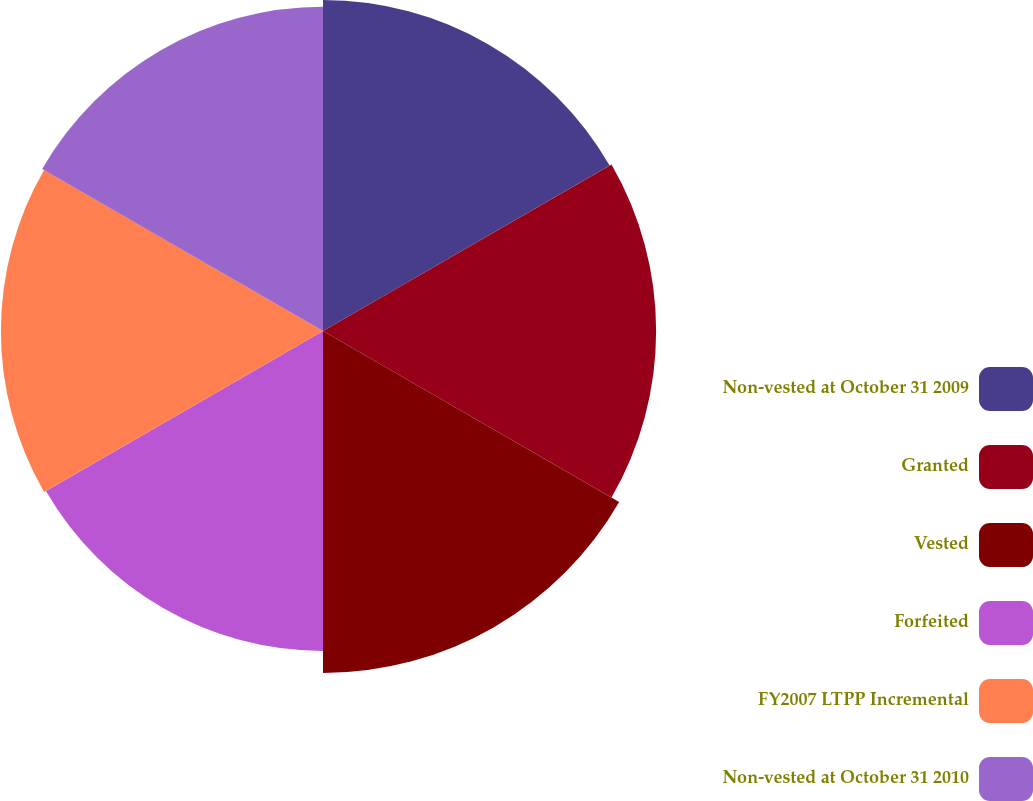Convert chart to OTSL. <chart><loc_0><loc_0><loc_500><loc_500><pie_chart><fcel>Non-vested at October 31 2009<fcel>Granted<fcel>Vested<fcel>Forfeited<fcel>FY2007 LTPP Incremental<fcel>Non-vested at October 31 2010<nl><fcel>16.78%<fcel>16.89%<fcel>17.34%<fcel>16.22%<fcel>16.33%<fcel>16.44%<nl></chart> 